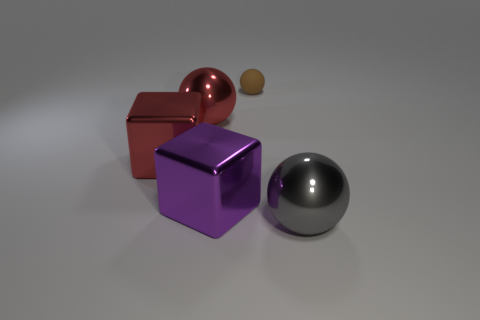Are there any big red shiny things that are to the left of the big metal ball that is on the right side of the brown thing behind the large red metal block?
Provide a short and direct response. Yes. There is a small rubber sphere; how many large gray metallic balls are behind it?
Ensure brevity in your answer.  0. How many large things are red metallic objects or rubber things?
Keep it short and to the point. 2. There is a large object that is in front of the purple metal cube; what is its shape?
Make the answer very short. Sphere. There is a shiny cube that is in front of the big red metal cube; is it the same size as the shiny thing that is behind the red metal cube?
Offer a terse response. Yes. Is the number of large shiny things that are to the right of the brown matte ball greater than the number of brown matte things that are in front of the red shiny block?
Keep it short and to the point. Yes. Is there a purple cube made of the same material as the large gray object?
Give a very brief answer. Yes. The object that is both to the right of the purple block and behind the gray metal ball is made of what material?
Offer a very short reply. Rubber. What color is the matte ball?
Your answer should be very brief. Brown. How many large purple shiny objects have the same shape as the small matte thing?
Offer a terse response. 0. 